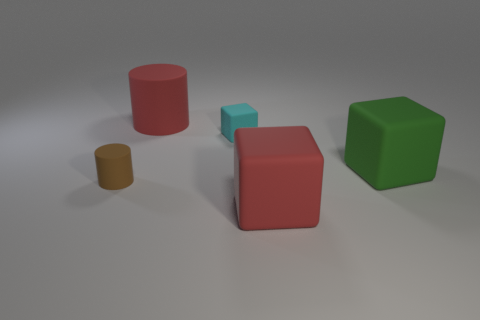There is a green block; is its size the same as the matte cylinder that is in front of the large red rubber cylinder? No, the green block is not the same size as the matte cylinder. The green block appears to be smaller in volume compared to the matte cylinder, which has a taller height. 